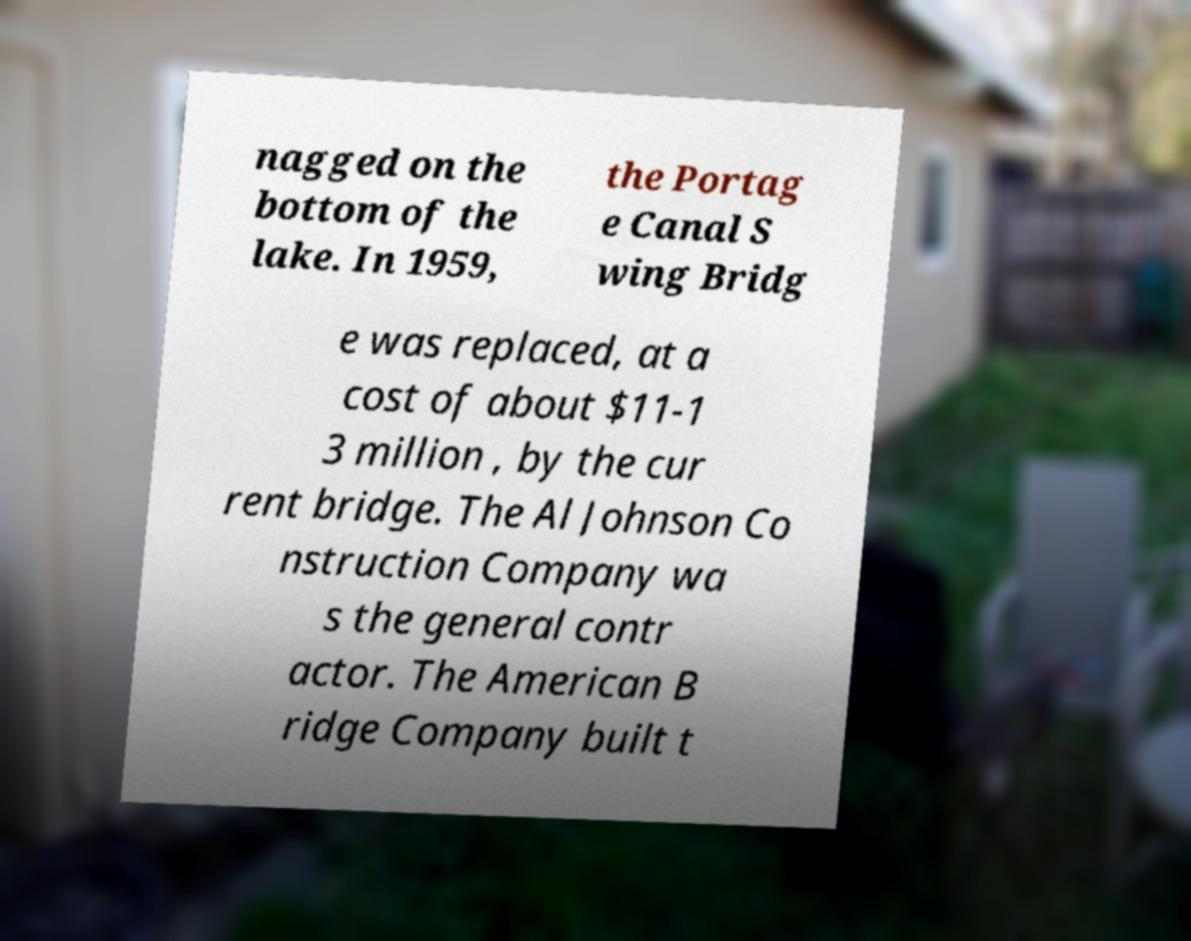Can you accurately transcribe the text from the provided image for me? nagged on the bottom of the lake. In 1959, the Portag e Canal S wing Bridg e was replaced, at a cost of about $11-1 3 million , by the cur rent bridge. The Al Johnson Co nstruction Company wa s the general contr actor. The American B ridge Company built t 